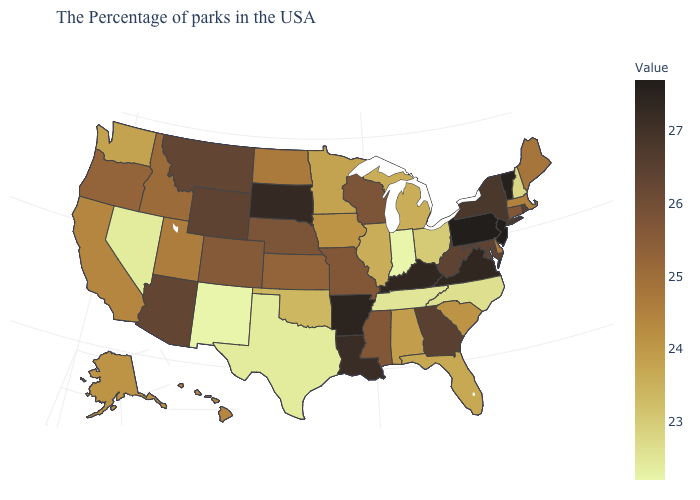Among the states that border South Carolina , which have the highest value?
Write a very short answer. Georgia. Which states have the highest value in the USA?
Concise answer only. New Jersey, Pennsylvania. Does New Mexico have the lowest value in the West?
Concise answer only. Yes. Among the states that border Florida , which have the highest value?
Quick response, please. Georgia. Which states have the lowest value in the USA?
Be succinct. Indiana, New Mexico. 